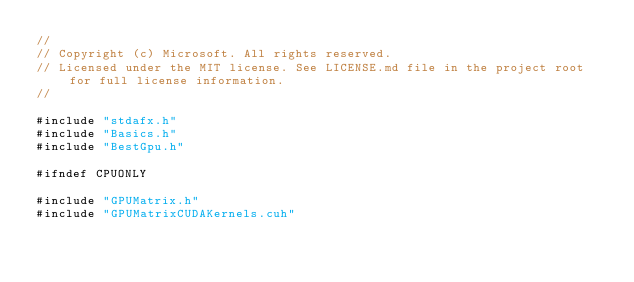<code> <loc_0><loc_0><loc_500><loc_500><_Cuda_>//
// Copyright (c) Microsoft. All rights reserved.
// Licensed under the MIT license. See LICENSE.md file in the project root for full license information.
//

#include "stdafx.h"
#include "Basics.h"
#include "BestGpu.h"

#ifndef CPUONLY

#include "GPUMatrix.h"
#include "GPUMatrixCUDAKernels.cuh"</code> 